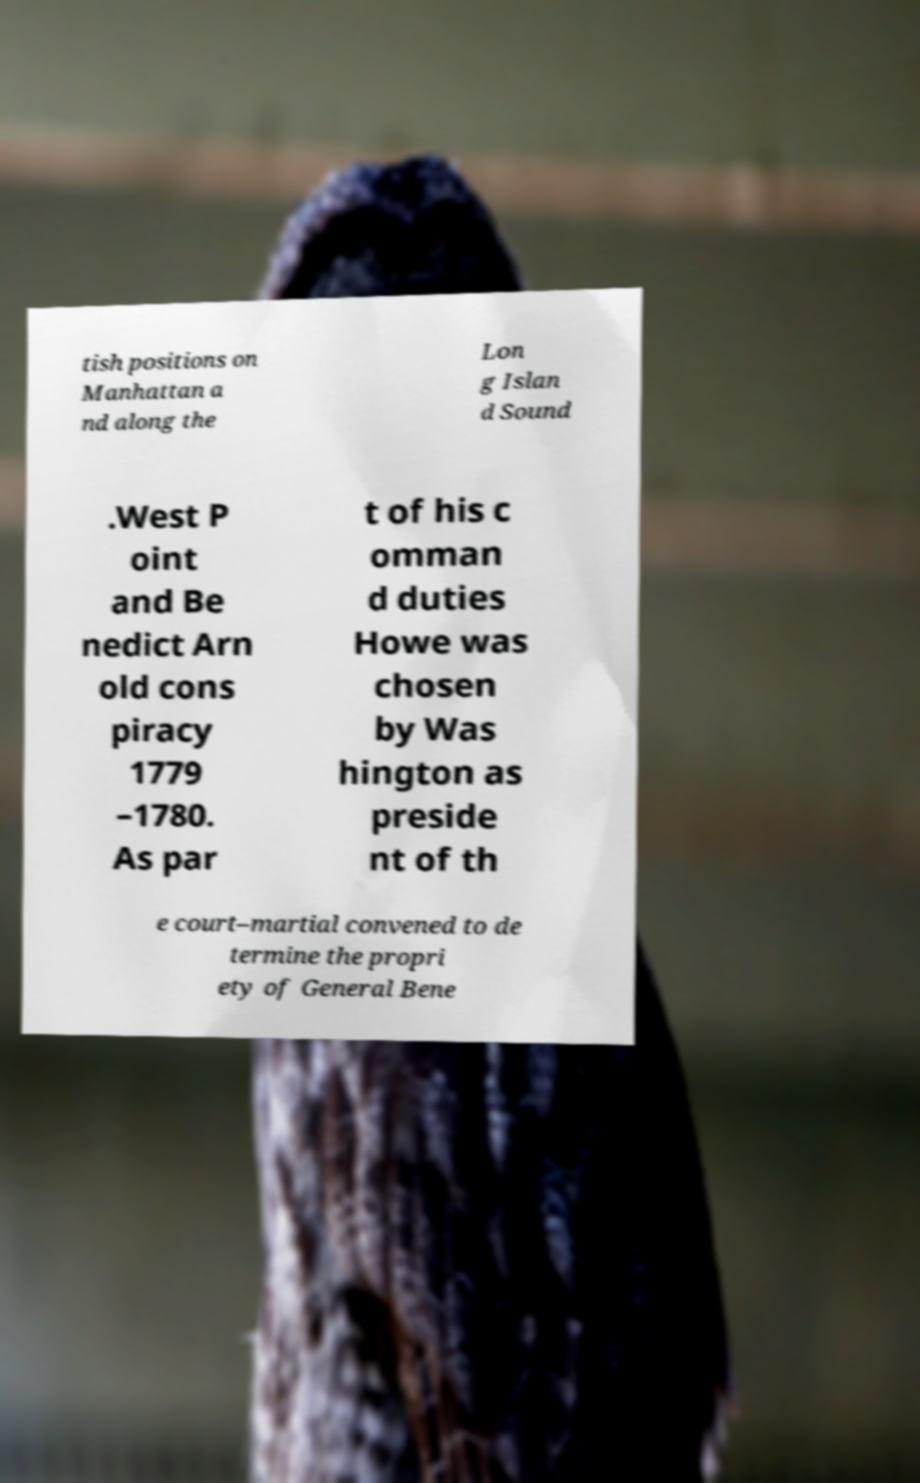Please identify and transcribe the text found in this image. tish positions on Manhattan a nd along the Lon g Islan d Sound .West P oint and Be nedict Arn old cons piracy 1779 –1780. As par t of his c omman d duties Howe was chosen by Was hington as preside nt of th e court–martial convened to de termine the propri ety of General Bene 